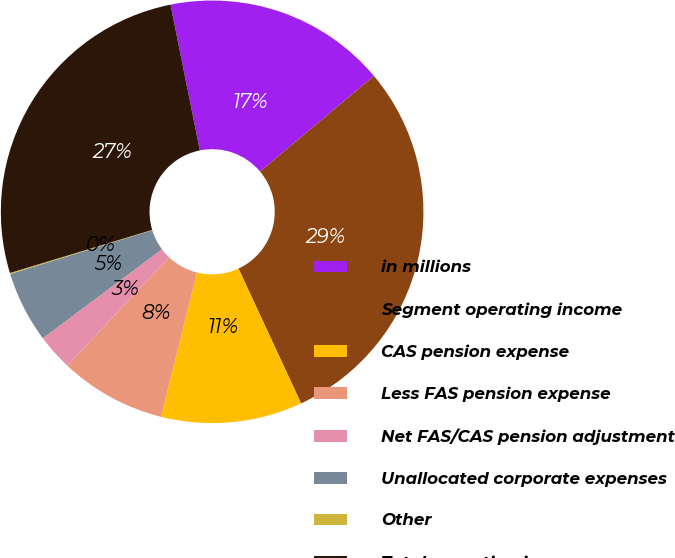Convert chart. <chart><loc_0><loc_0><loc_500><loc_500><pie_chart><fcel>in millions<fcel>Segment operating income<fcel>CAS pension expense<fcel>Less FAS pension expense<fcel>Net FAS/CAS pension adjustment<fcel>Unallocated corporate expenses<fcel>Other<fcel>Total operating income<nl><fcel>17.04%<fcel>29.2%<fcel>10.81%<fcel>8.13%<fcel>2.77%<fcel>5.45%<fcel>0.08%<fcel>26.52%<nl></chart> 